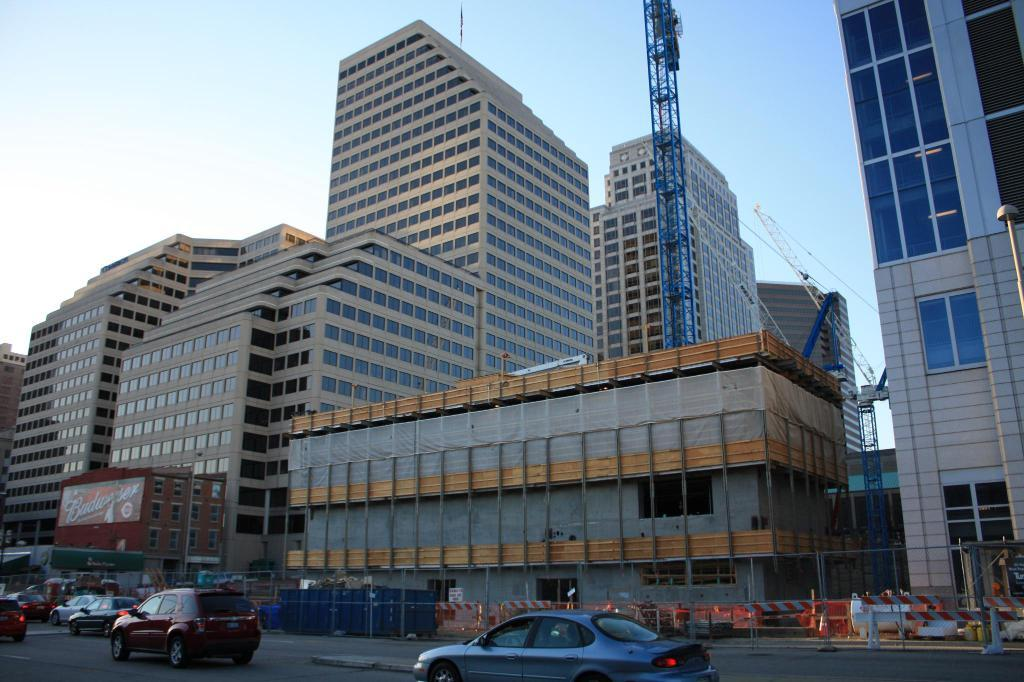What can be seen on the road in the image? There are cars on the road in the image. What type of barrier is present in the image? There is a fence in the image. What is hanging in the image? There is a banner in the image. What feature can be seen on the buildings in the image? The buildings in the image have windows. What is visible in the background of the image? The sky is visible in the background of the image. Can you see a chain wrapped around the banner in the image? There is no chain visible in the image; only the banner is present. What type of coil is used to support the cars on the road in the image? There is no coil present in the image; the cars are supported by the road itself. 